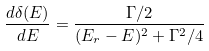<formula> <loc_0><loc_0><loc_500><loc_500>\frac { d \delta ( E ) } { d E } = \frac { \Gamma / 2 } { ( E _ { r } - E ) ^ { 2 } + \Gamma ^ { 2 } / 4 }</formula> 